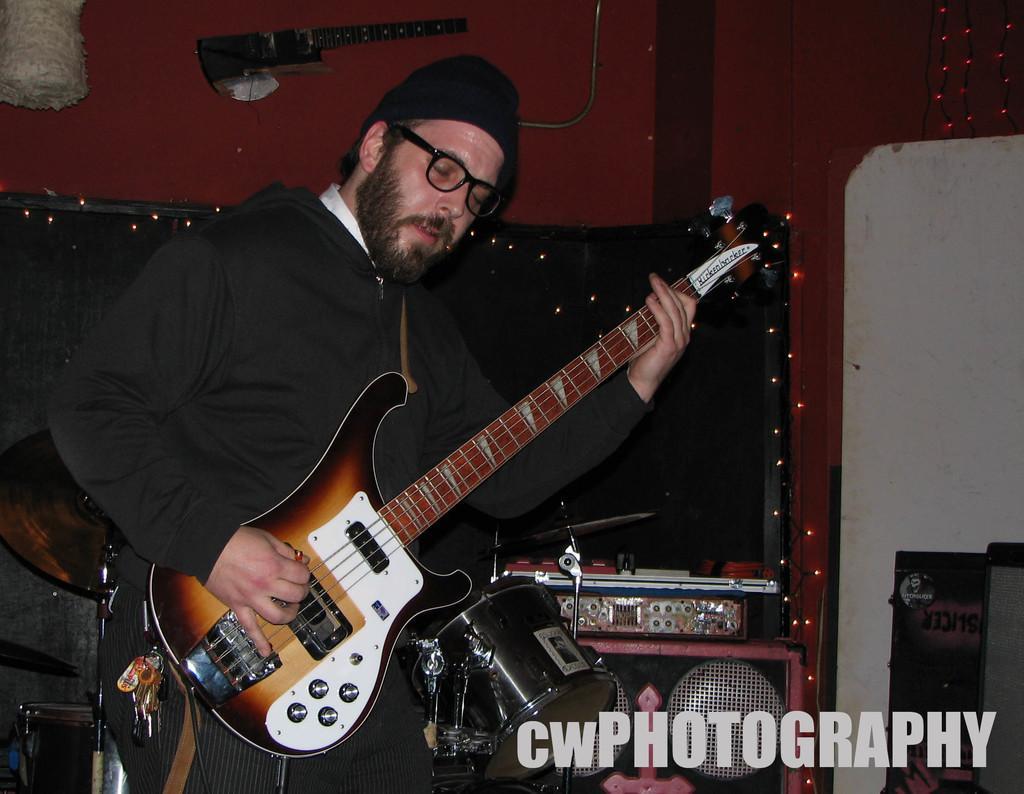How would you summarize this image in a sentence or two? This picture is of inside the room. In the center there is a man wearing black color hoodie, standing and playing guitar. On the bottom right corner there is a watermark on the image. In the background we can see a wall, decoration lights and some musical instruments. 